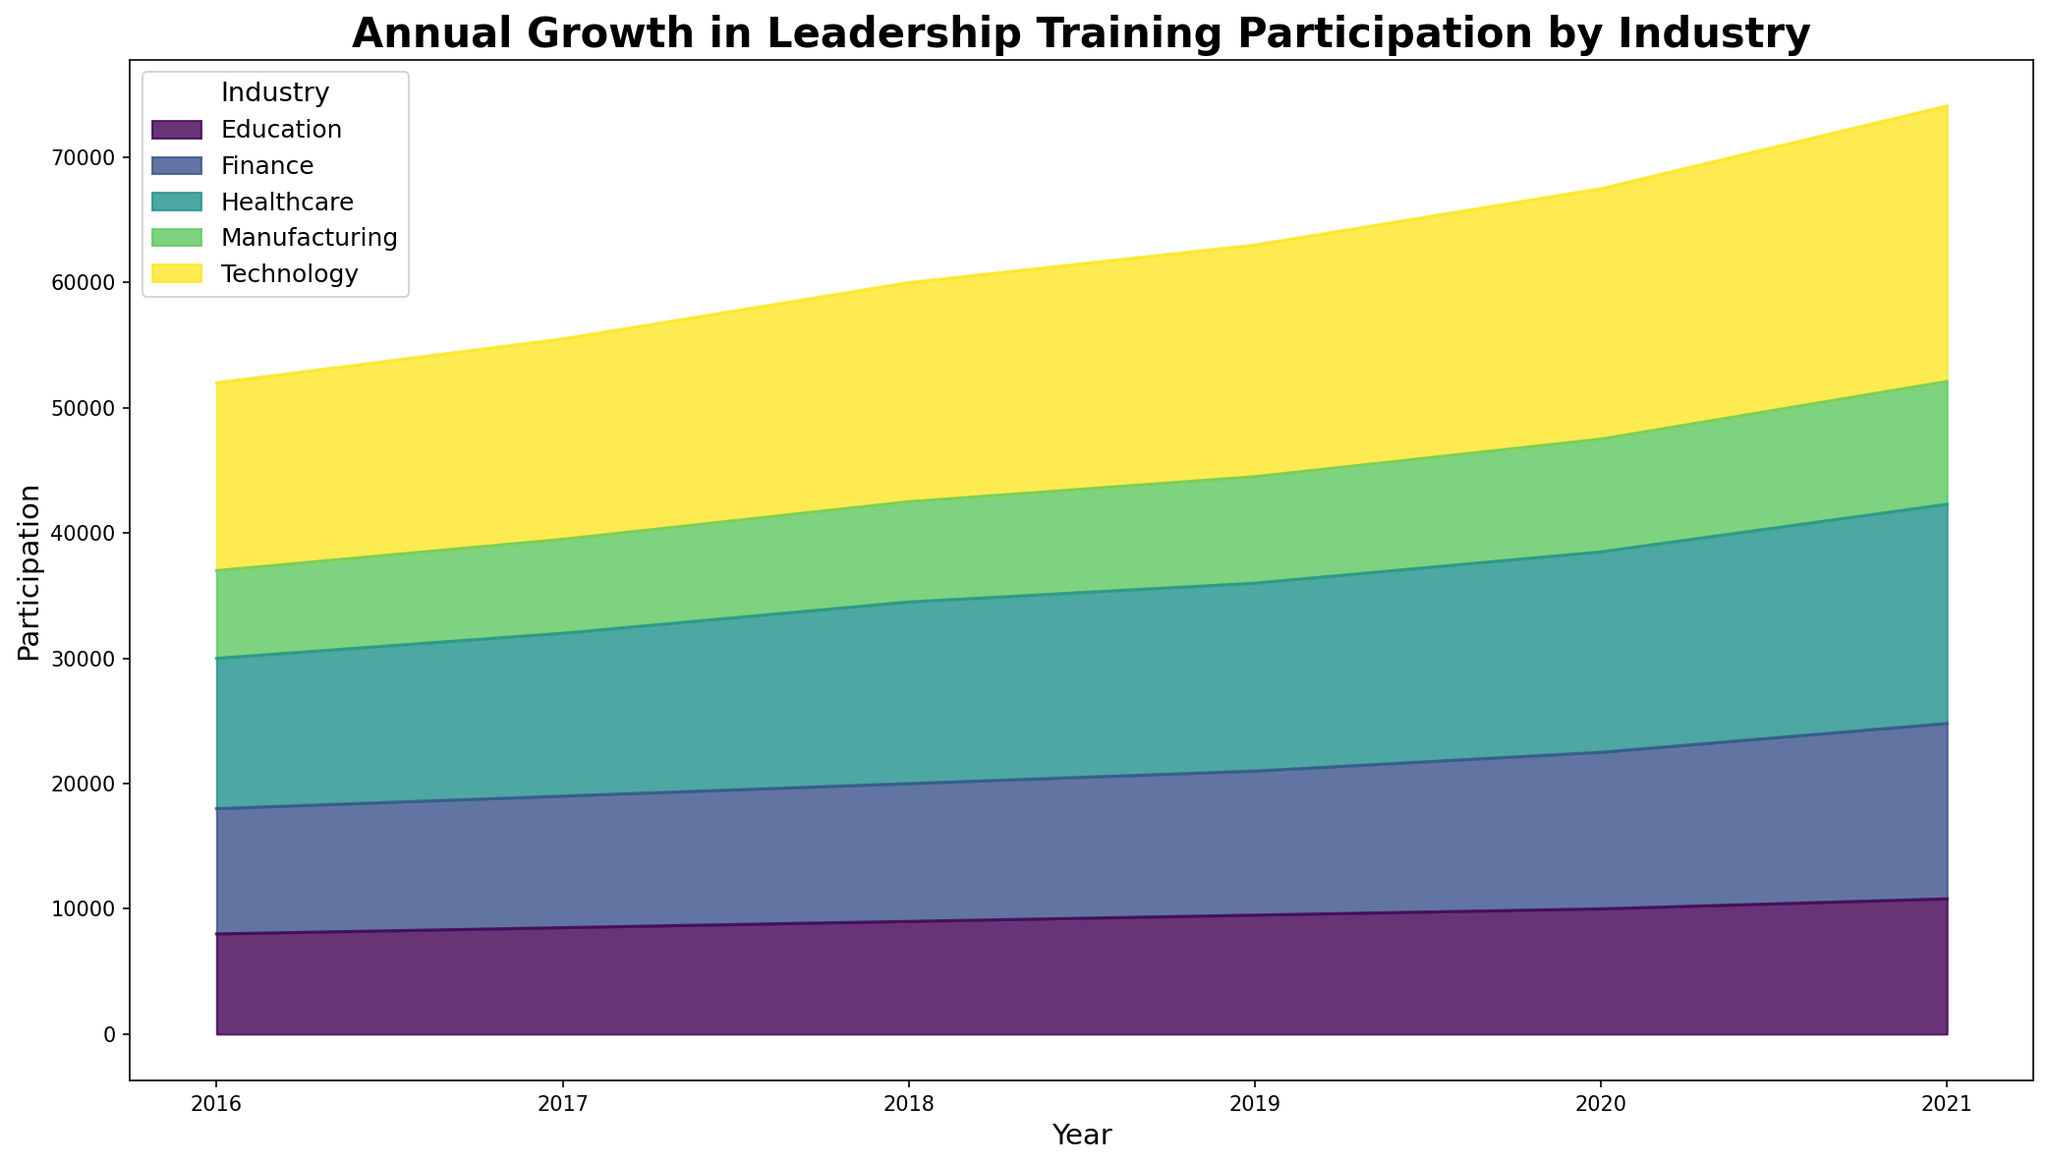Which industry had the highest participation in leadership training in 2021? Look at the height of the area chart for each industry in 2021. The tallest segment represents the Technology industry.
Answer: Technology How much did the participation in leadership training grow in the Healthcare industry from 2016 to 2021? Find the participation value for Healthcare in 2016 (12,000) and in 2021 (17,500). Subtract the 2016 value from the 2021 value: 17,500 - 12,000 = 5,500.
Answer: 5,500 In which year did the Finance industry experience the greatest increase in participation compared to the previous year? Examine the height difference in the area for Finance between consecutive years. The biggest increase appears between 2020 (12,500) and 2021 (14,000), which is 1,500.
Answer: 2021 Which two industries had the most similar participation levels in 2018, and what were those levels? Compare the heights of the areas for all industries for the year 2018. Finance (11,000) and Education (9,000) are the closest with a difference of 2,000.
Answer: Finance and Education, 11,000 and 9,000 What was the combined participation for Technology and Manufacturing industries in 2019? Look at the participation values for Technology (18,500) and Manufacturing (8,500) in 2019. Add these values together: 18,500 + 8,500 = 27,000.
Answer: 27,000 Between Healthcare and Education, which industry showed a higher rate of growth from 2016 to 2020? Calculate the growth for Healthcare from 12,000 (2016) to 16,000 (2020) which is 4,000, and for Education from 8,000 (2016) to 10,000 (2020) which is 2,000. Healthcare’s growth of 4,000 is higher than Education's 2,000.
Answer: Healthcare Which industry has the smallest segment in the area chart for 2016, and what is that value? Identify the shortest segment in 2016, which is for Manufacturing with a value of 7,000.
Answer: Manufacturing, 7,000 By how much did the participation in leadership training in the Technology industry increase from 2017 to 2018? Find the participation in Technology for 2017 (16,000) and 2018 (17,500). Subtract the 2017 value from the 2018 value: 17,500 - 16,000 = 1,500.
Answer: 1,500 